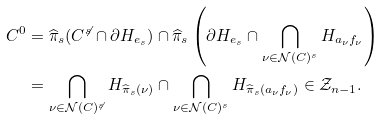Convert formula to latex. <formula><loc_0><loc_0><loc_500><loc_500>C ^ { 0 } & = \widehat { \pi } _ { s } ( C ^ { \not { s } } \cap \partial H _ { e _ { s } } ) \cap \widehat { \pi } _ { s } \left ( \partial H _ { e _ { s } } \cap \bigcap _ { \nu \in \mathcal { N } ( C ) ^ { s } } H _ { a _ { \nu } f _ { \nu } } \right ) \\ & = \bigcap _ { \nu \in \mathcal { N } ( C ) ^ { \not { s } } } H _ { \widehat { \pi } _ { s } ( \nu ) } \cap \bigcap _ { \nu \in \mathcal { N } ( C ) ^ { s } } H _ { \widehat { \pi } _ { s } ( a _ { \nu } f _ { \nu } ) } \in \mathcal { Z } _ { n - 1 } .</formula> 